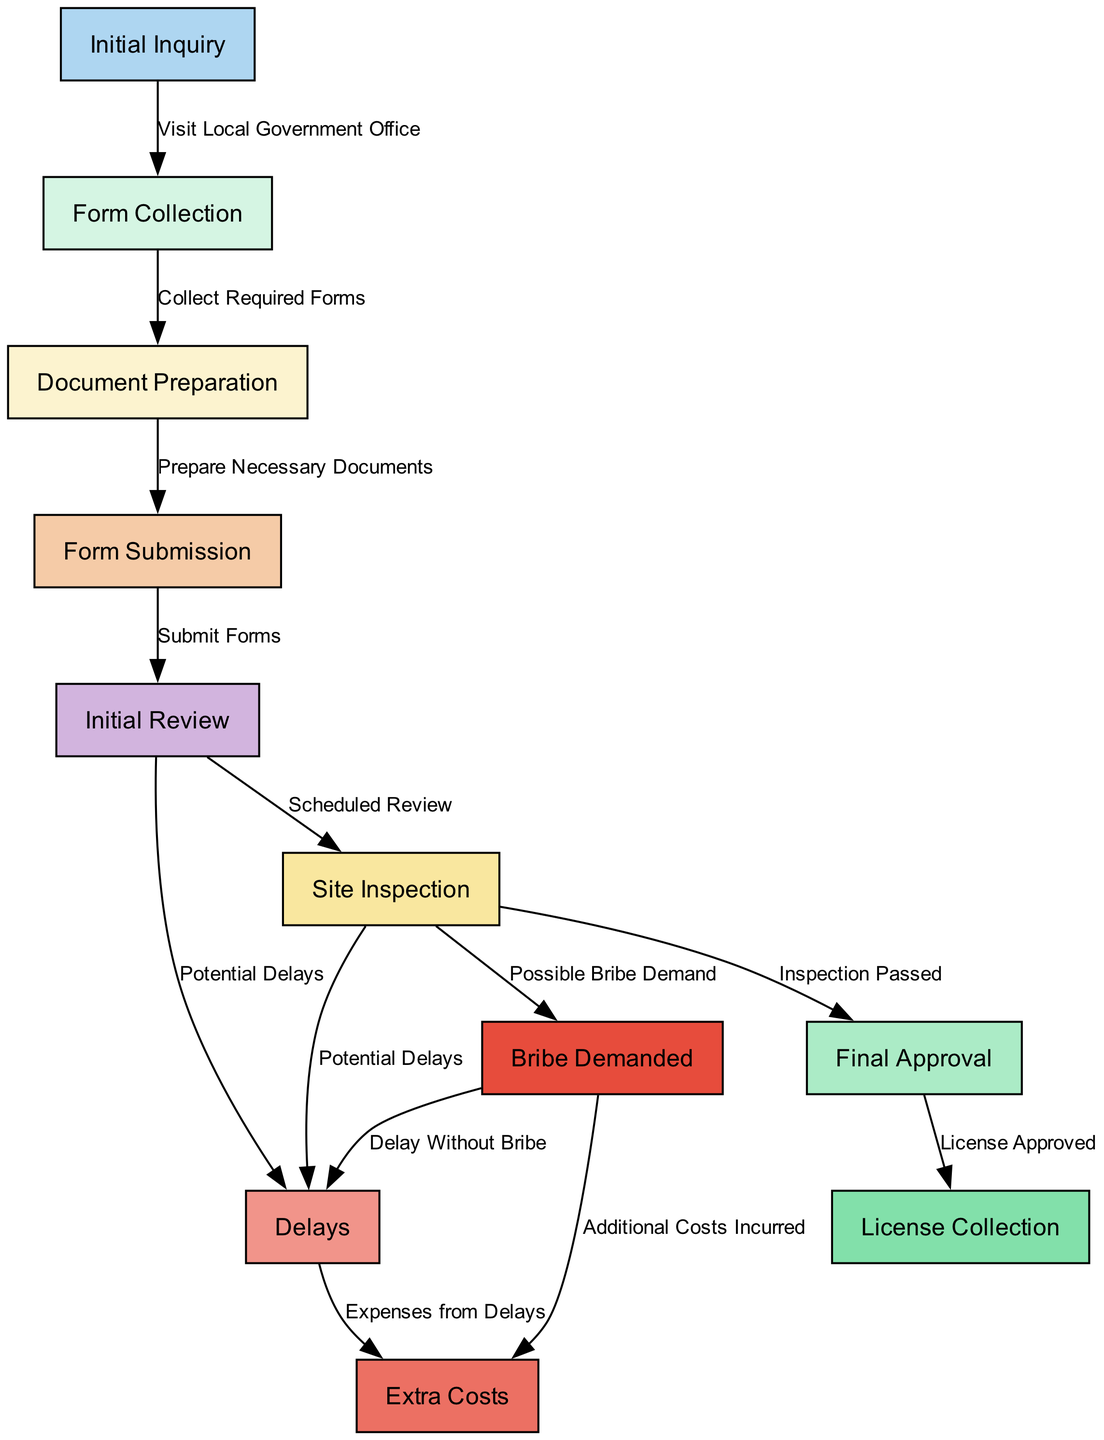What is the first step in obtaining a trade license? The first step is represented by the node "Initial Inquiry," which involves visiting a local government office.
Answer: Initial Inquiry How many nodes are there in the diagram? By counting all distinct processes and issues involved in the diagram, we find there are a total of 11 nodes.
Answer: 11 What happens after the form is collected? Once the "Form Collection" is completed, the next step is "Document Preparation," where necessary documents are prepared.
Answer: Document Preparation What is a possible consequence of the initial review? The initial review can lead to "Delays," indicating that there might be some waiting period or bottleneck before moving to the next step.
Answer: Delays What extra cost could be incurred during the process? The diagram indicates that "Bribe Demanded" can lead to "Extra Costs," implying that corruption can result in additional expenses.
Answer: Extra Costs Which node comes after site inspection if the inspection is passed? If the inspection is successful, the next step in the process is "Final Approval," where the license is reviewed for approval.
Answer: Final Approval How do delays relate to extra costs? The diagram shows that "Delays" can lead to "Extra Costs," suggesting that prolonged processing times can lead to financial repercussions.
Answer: Extra Costs What action is required after document preparation? Following the preparation of documents, the next action is "Form Submission," where the prepared forms should be submitted for review.
Answer: Form Submission What is the relationship between site inspection and official bribe? The diagram indicates that during the "Site Inspection," there is a possibility of a "Bribe Demanded," indicating a corrupt practice may occur.
Answer: Possible Bribe Demand 